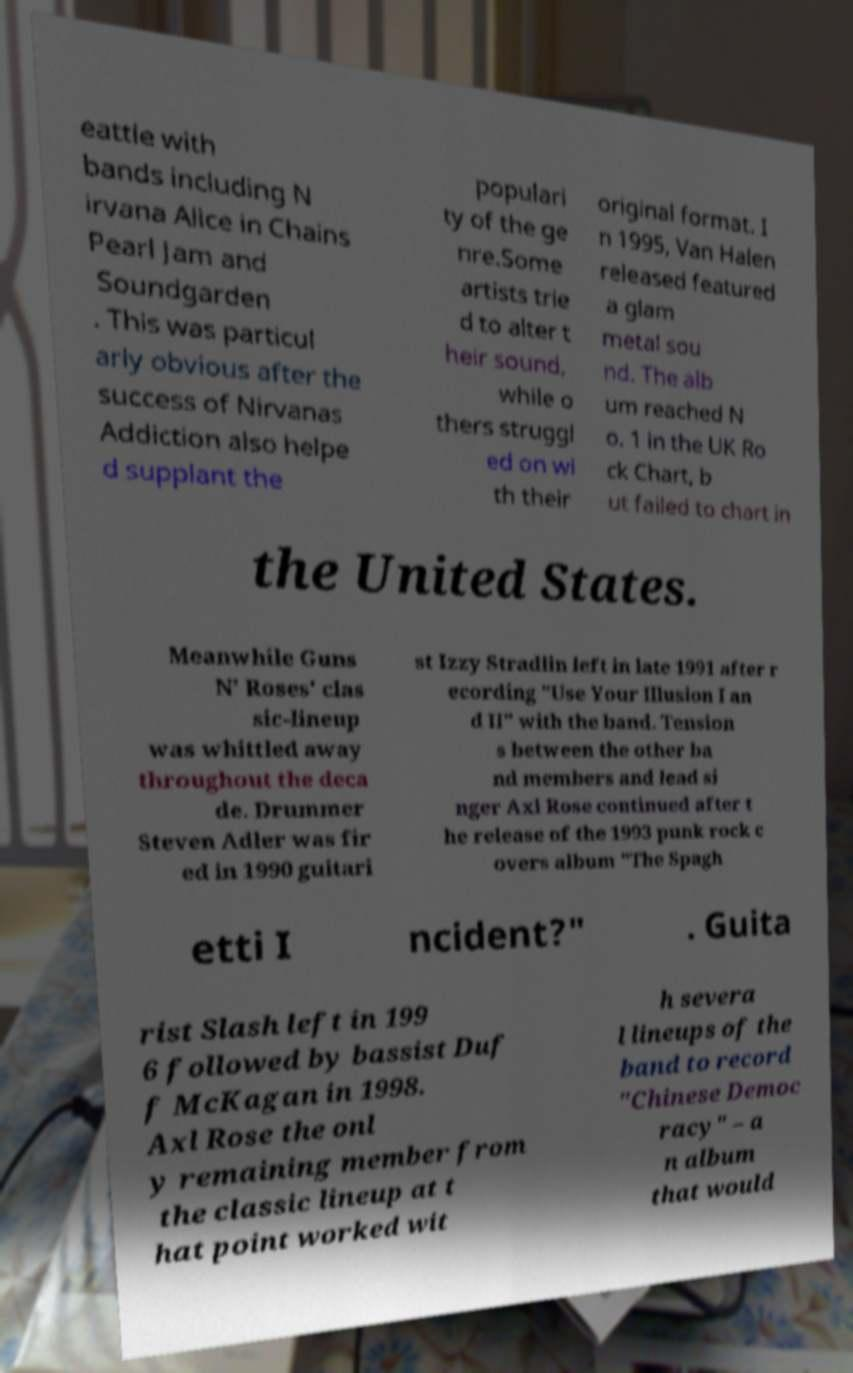Could you assist in decoding the text presented in this image and type it out clearly? eattle with bands including N irvana Alice in Chains Pearl Jam and Soundgarden . This was particul arly obvious after the success of Nirvanas Addiction also helpe d supplant the populari ty of the ge nre.Some artists trie d to alter t heir sound, while o thers struggl ed on wi th their original format. I n 1995, Van Halen released featured a glam metal sou nd. The alb um reached N o. 1 in the UK Ro ck Chart, b ut failed to chart in the United States. Meanwhile Guns N' Roses' clas sic-lineup was whittled away throughout the deca de. Drummer Steven Adler was fir ed in 1990 guitari st Izzy Stradlin left in late 1991 after r ecording "Use Your Illusion I an d II" with the band. Tension s between the other ba nd members and lead si nger Axl Rose continued after t he release of the 1993 punk rock c overs album "The Spagh etti I ncident?" . Guita rist Slash left in 199 6 followed by bassist Duf f McKagan in 1998. Axl Rose the onl y remaining member from the classic lineup at t hat point worked wit h severa l lineups of the band to record "Chinese Democ racy" – a n album that would 